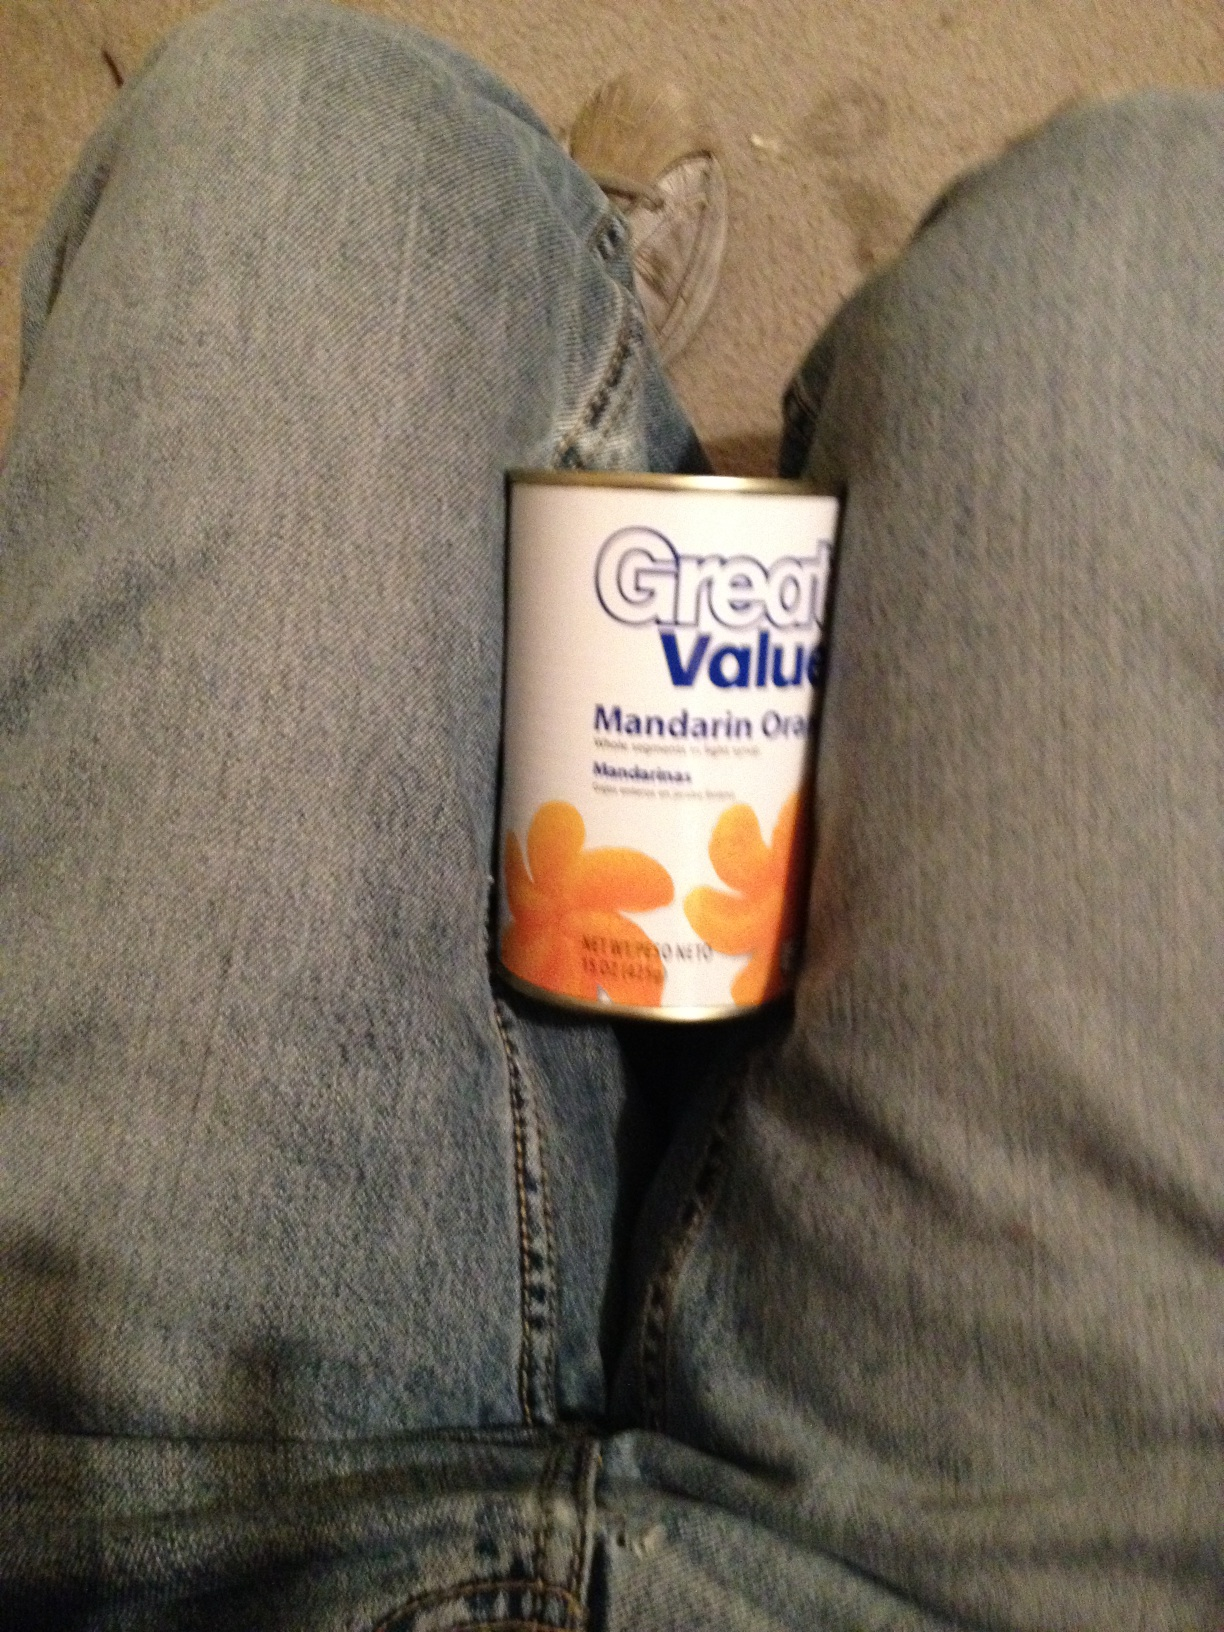Can you tell me more about what's in this can? This is a can of mandarin oranges from the Great Value brand. It typically contains peeled and segmented mandarin oranges immersed in light syrup. These are often used in salads, desserts, or eaten directly as a snack. What can I make with these mandarin oranges? Mandarin oranges can be quite versatile in the kitchen. You can use them to make a fresh fruit salad, add them to a leafy green salad for a sweet twist, or mix them into yogurt or cottage cheese. They're also great for making citrus-flavored desserts like mandarin orange cake, or you can blend them into smoothies for a refreshing drink. Imagine a fun, creative recipe involving these oranges! How about creating a 'Mandarin Orange Sunshine Pizza'? Start with a sweet flatbread or a cookie crust as the base. Spread a layer of cream cheese frosting over it, then top it with drained mandarin orange segments arranged like the sun's rays. Add a sprinkle of shredded coconut to resemble clouds and a drizzle of honey for extra sweetness. It's a delightful dessert pizza that looks as sunny and cheerful as it tastes! Describe a realistic scenario involving this can of mandarin oranges (short response). You're preparing a quick and healthy snack for your kids, so you open the can of mandarin oranges and serve them in small cups. The kids are delighted with the sweet and juicy treat. Describe a realistic scenario involving this can of mandarin oranges (long response). It's a Sunday afternoon, and you're planning a light and refreshing dinner for your family. You decide to make a mixed green salad with a citrus twist. You begin by opening a can of mandarin oranges, draining them, and setting them aside. You then prepare a bed of spinach and mixed greens, slicing some red onions and adding in some almonds for crunch. As you assemble the salad, you garnish it with the mandarin orange segments. To finish, you whip up a homemade citrus vinaigrette using orange juice, honey, Dijon mustard, and olive oil. Your family gathers around the table, and as they dig into the salad, the sweet and tangy flavor of the mandarin oranges pairs perfectly with the vinaigrette, making for a wonderfully wholesome and refreshing meal. 